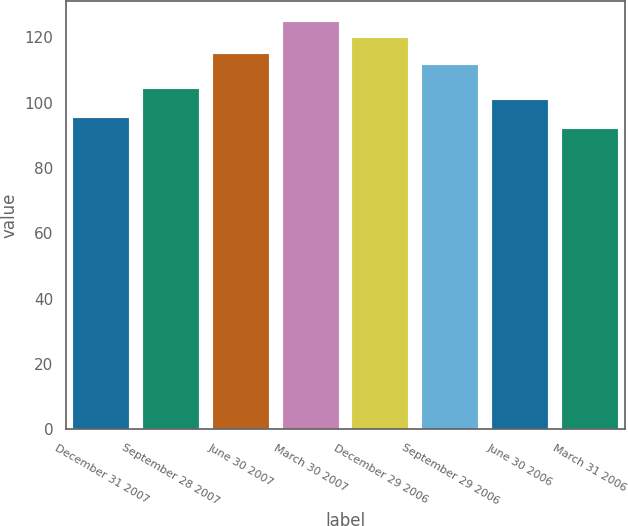<chart> <loc_0><loc_0><loc_500><loc_500><bar_chart><fcel>December 31 2007<fcel>September 28 2007<fcel>June 30 2007<fcel>March 30 2007<fcel>December 29 2006<fcel>September 29 2006<fcel>June 30 2006<fcel>March 31 2006<nl><fcel>95.37<fcel>104.17<fcel>114.81<fcel>124.78<fcel>119.76<fcel>111.54<fcel>100.9<fcel>92.1<nl></chart> 